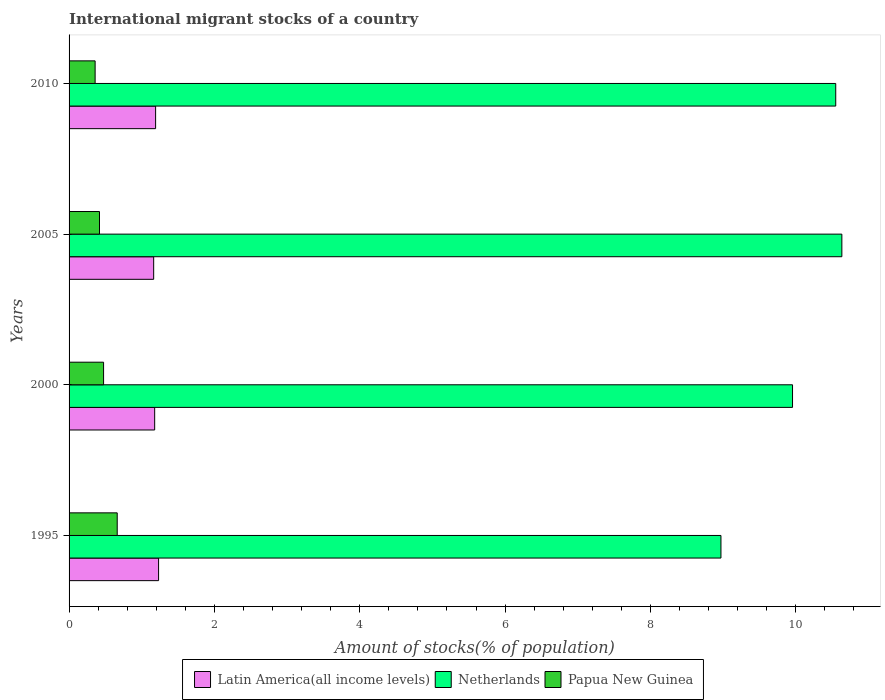How many groups of bars are there?
Offer a very short reply. 4. Are the number of bars per tick equal to the number of legend labels?
Offer a very short reply. Yes. What is the label of the 4th group of bars from the top?
Offer a very short reply. 1995. What is the amount of stocks in in Latin America(all income levels) in 2005?
Provide a succinct answer. 1.16. Across all years, what is the maximum amount of stocks in in Papua New Guinea?
Provide a short and direct response. 0.66. Across all years, what is the minimum amount of stocks in in Latin America(all income levels)?
Provide a succinct answer. 1.16. What is the total amount of stocks in in Netherlands in the graph?
Ensure brevity in your answer.  40.11. What is the difference between the amount of stocks in in Papua New Guinea in 1995 and that in 2010?
Offer a terse response. 0.3. What is the difference between the amount of stocks in in Papua New Guinea in 2010 and the amount of stocks in in Latin America(all income levels) in 1995?
Your response must be concise. -0.87. What is the average amount of stocks in in Papua New Guinea per year?
Keep it short and to the point. 0.48. In the year 2000, what is the difference between the amount of stocks in in Netherlands and amount of stocks in in Papua New Guinea?
Your answer should be compact. 9.48. What is the ratio of the amount of stocks in in Latin America(all income levels) in 1995 to that in 2000?
Provide a succinct answer. 1.05. Is the amount of stocks in in Latin America(all income levels) in 2000 less than that in 2010?
Provide a short and direct response. Yes. Is the difference between the amount of stocks in in Netherlands in 1995 and 2010 greater than the difference between the amount of stocks in in Papua New Guinea in 1995 and 2010?
Provide a short and direct response. No. What is the difference between the highest and the second highest amount of stocks in in Papua New Guinea?
Give a very brief answer. 0.19. What is the difference between the highest and the lowest amount of stocks in in Netherlands?
Make the answer very short. 1.66. Is the sum of the amount of stocks in in Latin America(all income levels) in 1995 and 2000 greater than the maximum amount of stocks in in Netherlands across all years?
Keep it short and to the point. No. What does the 3rd bar from the top in 2010 represents?
Provide a succinct answer. Latin America(all income levels). What does the 3rd bar from the bottom in 1995 represents?
Keep it short and to the point. Papua New Guinea. Is it the case that in every year, the sum of the amount of stocks in in Papua New Guinea and amount of stocks in in Latin America(all income levels) is greater than the amount of stocks in in Netherlands?
Keep it short and to the point. No. Does the graph contain any zero values?
Your answer should be compact. No. Where does the legend appear in the graph?
Provide a short and direct response. Bottom center. How many legend labels are there?
Keep it short and to the point. 3. What is the title of the graph?
Offer a very short reply. International migrant stocks of a country. Does "Lao PDR" appear as one of the legend labels in the graph?
Offer a very short reply. No. What is the label or title of the X-axis?
Keep it short and to the point. Amount of stocks(% of population). What is the label or title of the Y-axis?
Provide a succinct answer. Years. What is the Amount of stocks(% of population) of Latin America(all income levels) in 1995?
Offer a terse response. 1.23. What is the Amount of stocks(% of population) in Netherlands in 1995?
Ensure brevity in your answer.  8.97. What is the Amount of stocks(% of population) in Papua New Guinea in 1995?
Your answer should be compact. 0.66. What is the Amount of stocks(% of population) of Latin America(all income levels) in 2000?
Ensure brevity in your answer.  1.18. What is the Amount of stocks(% of population) of Netherlands in 2000?
Keep it short and to the point. 9.96. What is the Amount of stocks(% of population) of Papua New Guinea in 2000?
Offer a terse response. 0.47. What is the Amount of stocks(% of population) of Latin America(all income levels) in 2005?
Ensure brevity in your answer.  1.16. What is the Amount of stocks(% of population) in Netherlands in 2005?
Make the answer very short. 10.63. What is the Amount of stocks(% of population) of Papua New Guinea in 2005?
Keep it short and to the point. 0.42. What is the Amount of stocks(% of population) in Latin America(all income levels) in 2010?
Keep it short and to the point. 1.19. What is the Amount of stocks(% of population) of Netherlands in 2010?
Keep it short and to the point. 10.55. What is the Amount of stocks(% of population) of Papua New Guinea in 2010?
Your response must be concise. 0.36. Across all years, what is the maximum Amount of stocks(% of population) in Latin America(all income levels)?
Your response must be concise. 1.23. Across all years, what is the maximum Amount of stocks(% of population) in Netherlands?
Provide a succinct answer. 10.63. Across all years, what is the maximum Amount of stocks(% of population) of Papua New Guinea?
Your answer should be compact. 0.66. Across all years, what is the minimum Amount of stocks(% of population) in Latin America(all income levels)?
Ensure brevity in your answer.  1.16. Across all years, what is the minimum Amount of stocks(% of population) of Netherlands?
Your answer should be very brief. 8.97. Across all years, what is the minimum Amount of stocks(% of population) of Papua New Guinea?
Your answer should be compact. 0.36. What is the total Amount of stocks(% of population) of Latin America(all income levels) in the graph?
Provide a succinct answer. 4.76. What is the total Amount of stocks(% of population) in Netherlands in the graph?
Provide a short and direct response. 40.11. What is the total Amount of stocks(% of population) of Papua New Guinea in the graph?
Your response must be concise. 1.91. What is the difference between the Amount of stocks(% of population) in Latin America(all income levels) in 1995 and that in 2000?
Your response must be concise. 0.05. What is the difference between the Amount of stocks(% of population) of Netherlands in 1995 and that in 2000?
Ensure brevity in your answer.  -0.98. What is the difference between the Amount of stocks(% of population) of Papua New Guinea in 1995 and that in 2000?
Ensure brevity in your answer.  0.19. What is the difference between the Amount of stocks(% of population) of Latin America(all income levels) in 1995 and that in 2005?
Ensure brevity in your answer.  0.07. What is the difference between the Amount of stocks(% of population) of Netherlands in 1995 and that in 2005?
Make the answer very short. -1.66. What is the difference between the Amount of stocks(% of population) of Papua New Guinea in 1995 and that in 2005?
Make the answer very short. 0.24. What is the difference between the Amount of stocks(% of population) in Latin America(all income levels) in 1995 and that in 2010?
Offer a very short reply. 0.04. What is the difference between the Amount of stocks(% of population) of Netherlands in 1995 and that in 2010?
Offer a terse response. -1.58. What is the difference between the Amount of stocks(% of population) in Papua New Guinea in 1995 and that in 2010?
Your answer should be very brief. 0.3. What is the difference between the Amount of stocks(% of population) of Latin America(all income levels) in 2000 and that in 2005?
Offer a very short reply. 0.01. What is the difference between the Amount of stocks(% of population) of Netherlands in 2000 and that in 2005?
Provide a short and direct response. -0.68. What is the difference between the Amount of stocks(% of population) in Papua New Guinea in 2000 and that in 2005?
Keep it short and to the point. 0.06. What is the difference between the Amount of stocks(% of population) of Latin America(all income levels) in 2000 and that in 2010?
Offer a very short reply. -0.01. What is the difference between the Amount of stocks(% of population) of Netherlands in 2000 and that in 2010?
Offer a very short reply. -0.59. What is the difference between the Amount of stocks(% of population) in Papua New Guinea in 2000 and that in 2010?
Your answer should be compact. 0.12. What is the difference between the Amount of stocks(% of population) in Latin America(all income levels) in 2005 and that in 2010?
Give a very brief answer. -0.03. What is the difference between the Amount of stocks(% of population) in Netherlands in 2005 and that in 2010?
Keep it short and to the point. 0.08. What is the difference between the Amount of stocks(% of population) in Papua New Guinea in 2005 and that in 2010?
Provide a succinct answer. 0.06. What is the difference between the Amount of stocks(% of population) in Latin America(all income levels) in 1995 and the Amount of stocks(% of population) in Netherlands in 2000?
Ensure brevity in your answer.  -8.72. What is the difference between the Amount of stocks(% of population) in Latin America(all income levels) in 1995 and the Amount of stocks(% of population) in Papua New Guinea in 2000?
Your answer should be compact. 0.76. What is the difference between the Amount of stocks(% of population) of Netherlands in 1995 and the Amount of stocks(% of population) of Papua New Guinea in 2000?
Your answer should be compact. 8.5. What is the difference between the Amount of stocks(% of population) in Latin America(all income levels) in 1995 and the Amount of stocks(% of population) in Netherlands in 2005?
Provide a short and direct response. -9.4. What is the difference between the Amount of stocks(% of population) in Latin America(all income levels) in 1995 and the Amount of stocks(% of population) in Papua New Guinea in 2005?
Your answer should be compact. 0.81. What is the difference between the Amount of stocks(% of population) in Netherlands in 1995 and the Amount of stocks(% of population) in Papua New Guinea in 2005?
Your answer should be very brief. 8.55. What is the difference between the Amount of stocks(% of population) of Latin America(all income levels) in 1995 and the Amount of stocks(% of population) of Netherlands in 2010?
Offer a very short reply. -9.32. What is the difference between the Amount of stocks(% of population) in Latin America(all income levels) in 1995 and the Amount of stocks(% of population) in Papua New Guinea in 2010?
Ensure brevity in your answer.  0.87. What is the difference between the Amount of stocks(% of population) in Netherlands in 1995 and the Amount of stocks(% of population) in Papua New Guinea in 2010?
Give a very brief answer. 8.61. What is the difference between the Amount of stocks(% of population) in Latin America(all income levels) in 2000 and the Amount of stocks(% of population) in Netherlands in 2005?
Your response must be concise. -9.46. What is the difference between the Amount of stocks(% of population) of Latin America(all income levels) in 2000 and the Amount of stocks(% of population) of Papua New Guinea in 2005?
Make the answer very short. 0.76. What is the difference between the Amount of stocks(% of population) of Netherlands in 2000 and the Amount of stocks(% of population) of Papua New Guinea in 2005?
Provide a short and direct response. 9.54. What is the difference between the Amount of stocks(% of population) of Latin America(all income levels) in 2000 and the Amount of stocks(% of population) of Netherlands in 2010?
Give a very brief answer. -9.37. What is the difference between the Amount of stocks(% of population) in Latin America(all income levels) in 2000 and the Amount of stocks(% of population) in Papua New Guinea in 2010?
Your response must be concise. 0.82. What is the difference between the Amount of stocks(% of population) of Netherlands in 2000 and the Amount of stocks(% of population) of Papua New Guinea in 2010?
Your answer should be very brief. 9.6. What is the difference between the Amount of stocks(% of population) of Latin America(all income levels) in 2005 and the Amount of stocks(% of population) of Netherlands in 2010?
Your response must be concise. -9.39. What is the difference between the Amount of stocks(% of population) of Latin America(all income levels) in 2005 and the Amount of stocks(% of population) of Papua New Guinea in 2010?
Provide a short and direct response. 0.81. What is the difference between the Amount of stocks(% of population) in Netherlands in 2005 and the Amount of stocks(% of population) in Papua New Guinea in 2010?
Provide a succinct answer. 10.28. What is the average Amount of stocks(% of population) in Latin America(all income levels) per year?
Your answer should be very brief. 1.19. What is the average Amount of stocks(% of population) of Netherlands per year?
Give a very brief answer. 10.03. What is the average Amount of stocks(% of population) in Papua New Guinea per year?
Your answer should be very brief. 0.48. In the year 1995, what is the difference between the Amount of stocks(% of population) in Latin America(all income levels) and Amount of stocks(% of population) in Netherlands?
Your response must be concise. -7.74. In the year 1995, what is the difference between the Amount of stocks(% of population) in Latin America(all income levels) and Amount of stocks(% of population) in Papua New Guinea?
Your answer should be compact. 0.57. In the year 1995, what is the difference between the Amount of stocks(% of population) in Netherlands and Amount of stocks(% of population) in Papua New Guinea?
Ensure brevity in your answer.  8.31. In the year 2000, what is the difference between the Amount of stocks(% of population) in Latin America(all income levels) and Amount of stocks(% of population) in Netherlands?
Your response must be concise. -8.78. In the year 2000, what is the difference between the Amount of stocks(% of population) of Latin America(all income levels) and Amount of stocks(% of population) of Papua New Guinea?
Make the answer very short. 0.7. In the year 2000, what is the difference between the Amount of stocks(% of population) of Netherlands and Amount of stocks(% of population) of Papua New Guinea?
Ensure brevity in your answer.  9.48. In the year 2005, what is the difference between the Amount of stocks(% of population) in Latin America(all income levels) and Amount of stocks(% of population) in Netherlands?
Provide a succinct answer. -9.47. In the year 2005, what is the difference between the Amount of stocks(% of population) of Latin America(all income levels) and Amount of stocks(% of population) of Papua New Guinea?
Provide a succinct answer. 0.75. In the year 2005, what is the difference between the Amount of stocks(% of population) in Netherlands and Amount of stocks(% of population) in Papua New Guinea?
Make the answer very short. 10.21. In the year 2010, what is the difference between the Amount of stocks(% of population) of Latin America(all income levels) and Amount of stocks(% of population) of Netherlands?
Your answer should be very brief. -9.36. In the year 2010, what is the difference between the Amount of stocks(% of population) in Latin America(all income levels) and Amount of stocks(% of population) in Papua New Guinea?
Offer a very short reply. 0.83. In the year 2010, what is the difference between the Amount of stocks(% of population) in Netherlands and Amount of stocks(% of population) in Papua New Guinea?
Keep it short and to the point. 10.19. What is the ratio of the Amount of stocks(% of population) in Latin America(all income levels) in 1995 to that in 2000?
Provide a succinct answer. 1.05. What is the ratio of the Amount of stocks(% of population) of Netherlands in 1995 to that in 2000?
Your answer should be compact. 0.9. What is the ratio of the Amount of stocks(% of population) in Papua New Guinea in 1995 to that in 2000?
Offer a terse response. 1.4. What is the ratio of the Amount of stocks(% of population) of Latin America(all income levels) in 1995 to that in 2005?
Offer a very short reply. 1.06. What is the ratio of the Amount of stocks(% of population) of Netherlands in 1995 to that in 2005?
Keep it short and to the point. 0.84. What is the ratio of the Amount of stocks(% of population) in Papua New Guinea in 1995 to that in 2005?
Ensure brevity in your answer.  1.58. What is the ratio of the Amount of stocks(% of population) in Latin America(all income levels) in 1995 to that in 2010?
Your answer should be compact. 1.03. What is the ratio of the Amount of stocks(% of population) of Netherlands in 1995 to that in 2010?
Give a very brief answer. 0.85. What is the ratio of the Amount of stocks(% of population) in Papua New Guinea in 1995 to that in 2010?
Offer a very short reply. 1.85. What is the ratio of the Amount of stocks(% of population) in Latin America(all income levels) in 2000 to that in 2005?
Offer a very short reply. 1.01. What is the ratio of the Amount of stocks(% of population) in Netherlands in 2000 to that in 2005?
Make the answer very short. 0.94. What is the ratio of the Amount of stocks(% of population) in Papua New Guinea in 2000 to that in 2005?
Provide a short and direct response. 1.13. What is the ratio of the Amount of stocks(% of population) in Netherlands in 2000 to that in 2010?
Offer a terse response. 0.94. What is the ratio of the Amount of stocks(% of population) of Papua New Guinea in 2000 to that in 2010?
Ensure brevity in your answer.  1.32. What is the ratio of the Amount of stocks(% of population) of Latin America(all income levels) in 2005 to that in 2010?
Give a very brief answer. 0.98. What is the ratio of the Amount of stocks(% of population) in Papua New Guinea in 2005 to that in 2010?
Offer a very short reply. 1.17. What is the difference between the highest and the second highest Amount of stocks(% of population) of Latin America(all income levels)?
Make the answer very short. 0.04. What is the difference between the highest and the second highest Amount of stocks(% of population) of Netherlands?
Give a very brief answer. 0.08. What is the difference between the highest and the second highest Amount of stocks(% of population) in Papua New Guinea?
Ensure brevity in your answer.  0.19. What is the difference between the highest and the lowest Amount of stocks(% of population) of Latin America(all income levels)?
Give a very brief answer. 0.07. What is the difference between the highest and the lowest Amount of stocks(% of population) in Netherlands?
Your answer should be very brief. 1.66. What is the difference between the highest and the lowest Amount of stocks(% of population) of Papua New Guinea?
Offer a terse response. 0.3. 